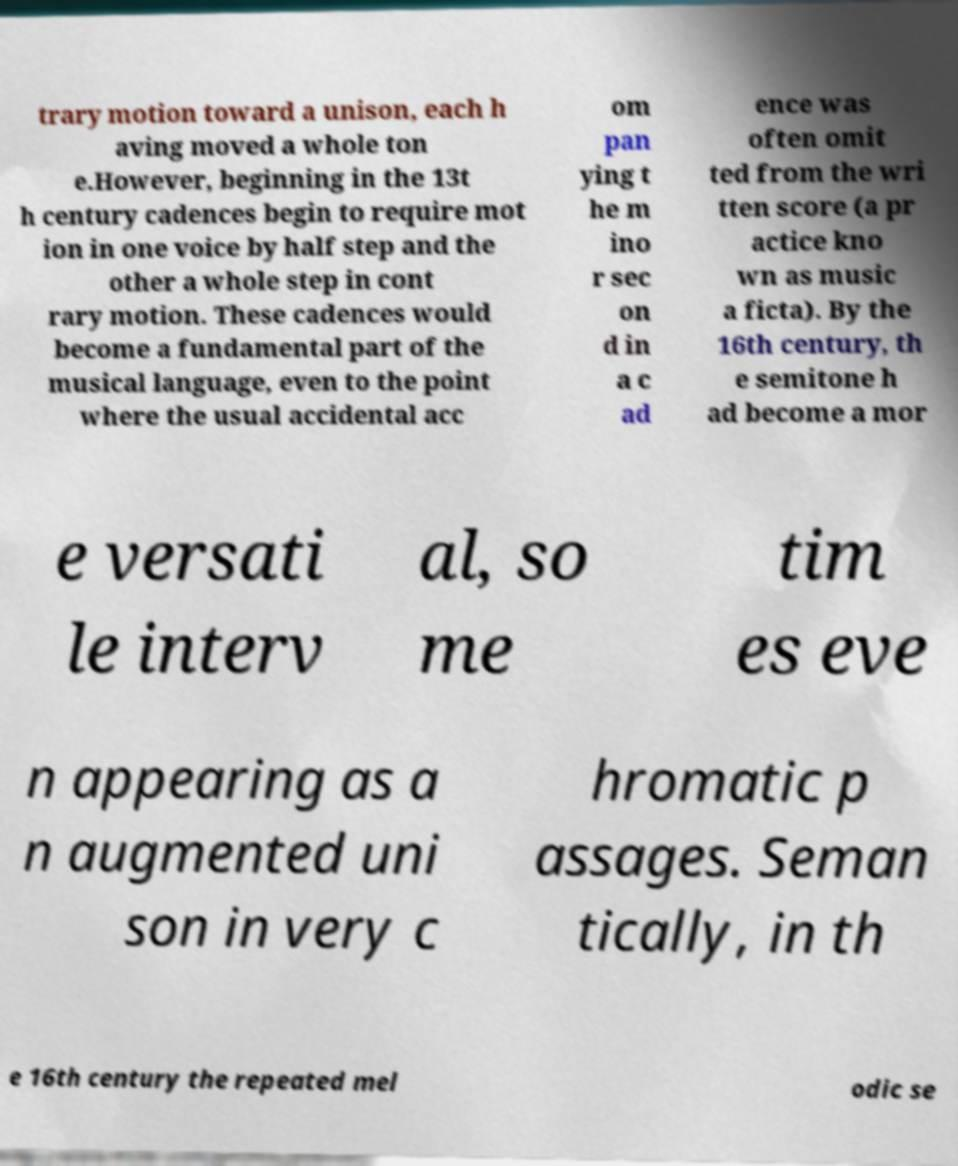Please identify and transcribe the text found in this image. trary motion toward a unison, each h aving moved a whole ton e.However, beginning in the 13t h century cadences begin to require mot ion in one voice by half step and the other a whole step in cont rary motion. These cadences would become a fundamental part of the musical language, even to the point where the usual accidental acc om pan ying t he m ino r sec on d in a c ad ence was often omit ted from the wri tten score (a pr actice kno wn as music a ficta). By the 16th century, th e semitone h ad become a mor e versati le interv al, so me tim es eve n appearing as a n augmented uni son in very c hromatic p assages. Seman tically, in th e 16th century the repeated mel odic se 